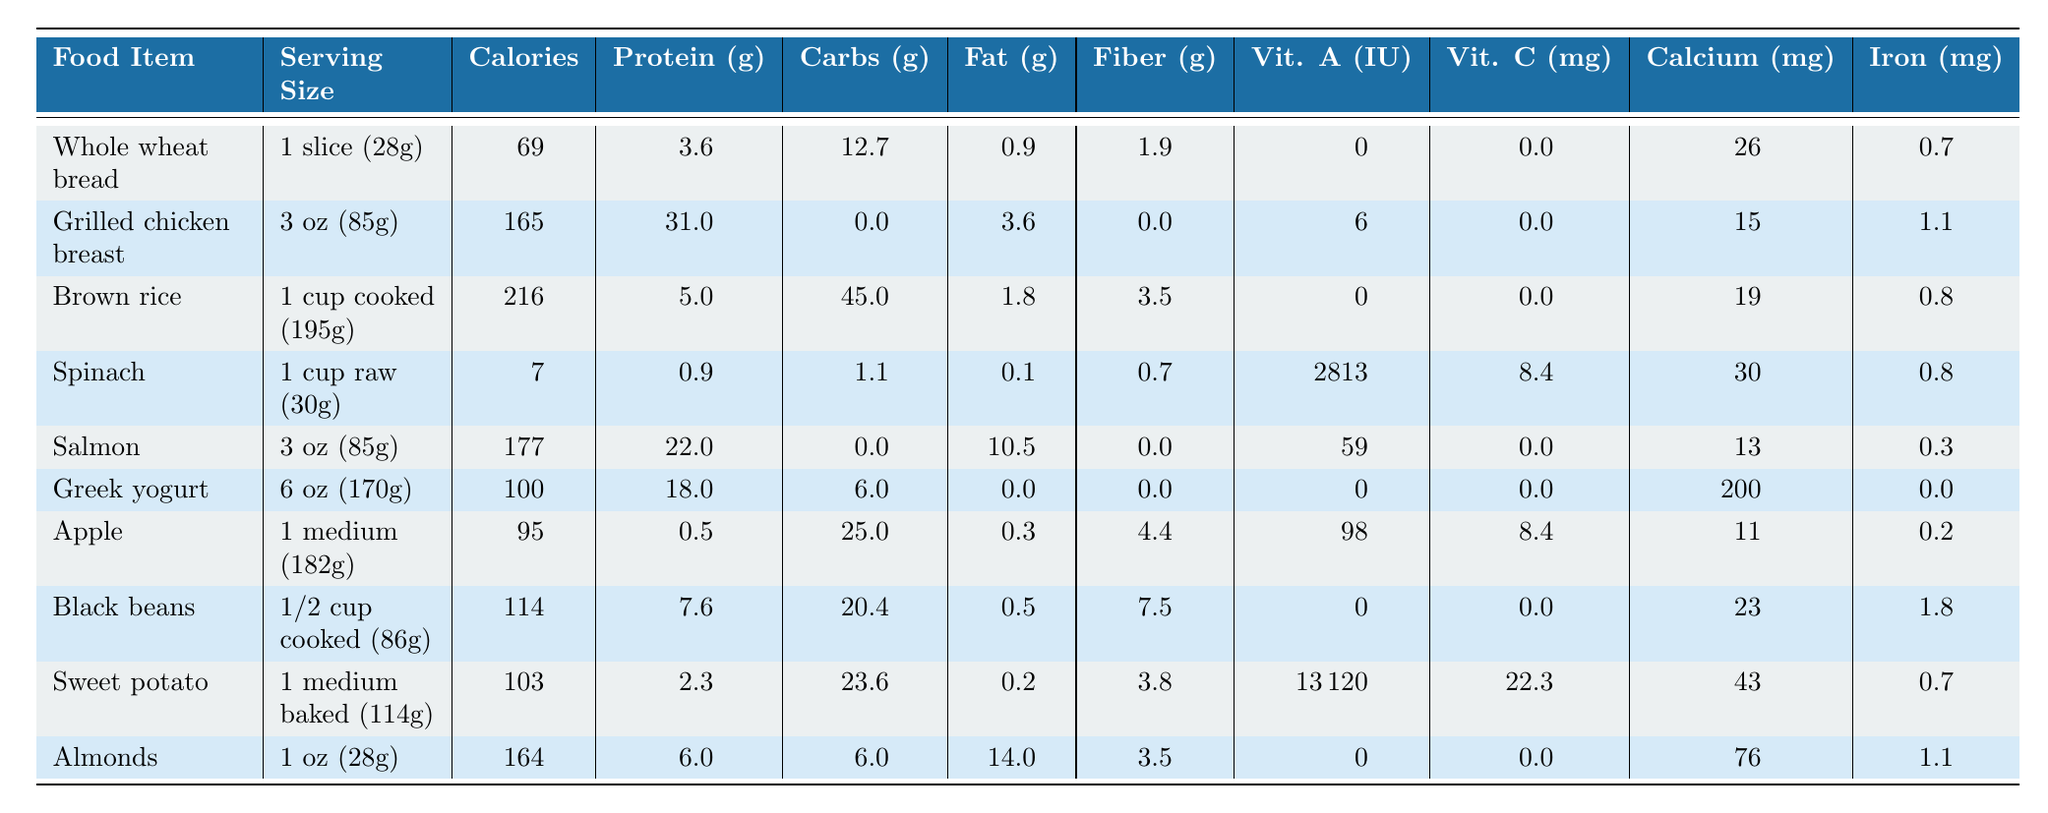What food item has the highest calories? By examining the "Calories" column, we see that "Brown rice" has the highest value at 216 calories per serving.
Answer: Brown rice What is the serving size of Greek yogurt? The table states the serving size for Greek yogurt is 6 oz (170g).
Answer: 6 oz (170g) Which food contains the most protein per serving? Looking at the "Protein" column, "Grilled chicken breast" has the highest protein content at 31 grams.
Answer: Grilled chicken breast What is the total carbohydrate content in Whole wheat bread and Brown rice? To find the total, we sum the carbohydrates: Whole wheat bread (12.7g) + Brown rice (45g) = 57.7g.
Answer: 57.7g Is Sweet potato a good source of Vitamin A? Yes, the Sweet potato has a Vitamin A content of 13,120 IU, which is significantly high.
Answer: Yes How many grams of fiber does Black beans provide? The "Fiber" column shows that Black beans provide 7.5 grams of fiber per serving.
Answer: 7.5g Which food has the least amount of calories? A quick look at the "Calories" column indicates that "Spinach" has the least amount of calories at only 7.
Answer: Spinach What is the average protein content of nuts and beans? We calculate the average: Almonds (6g) + Black beans (7.6g) = 13.6g, divided by 2 gives an average of 6.8g.
Answer: 6.8g Which food item has a serving that is highest in fat? The "Fat" column shows that "Almonds" has the highest fat content at 14 grams per serving.
Answer: Almonds Do any of the food items contain vitamin C? Yes, both Sweet potato (22.3 mg) and Apple (8.4 mg) contain vitamin C, indicating they are significant sources.
Answer: Yes 